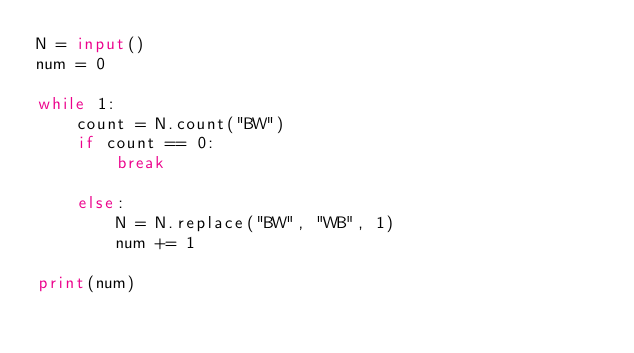<code> <loc_0><loc_0><loc_500><loc_500><_Python_>N = input()
num = 0

while 1:
    count = N.count("BW")
    if count == 0:
        break
    
    else:
        N = N.replace("BW", "WB", 1)
        num += 1

print(num)</code> 